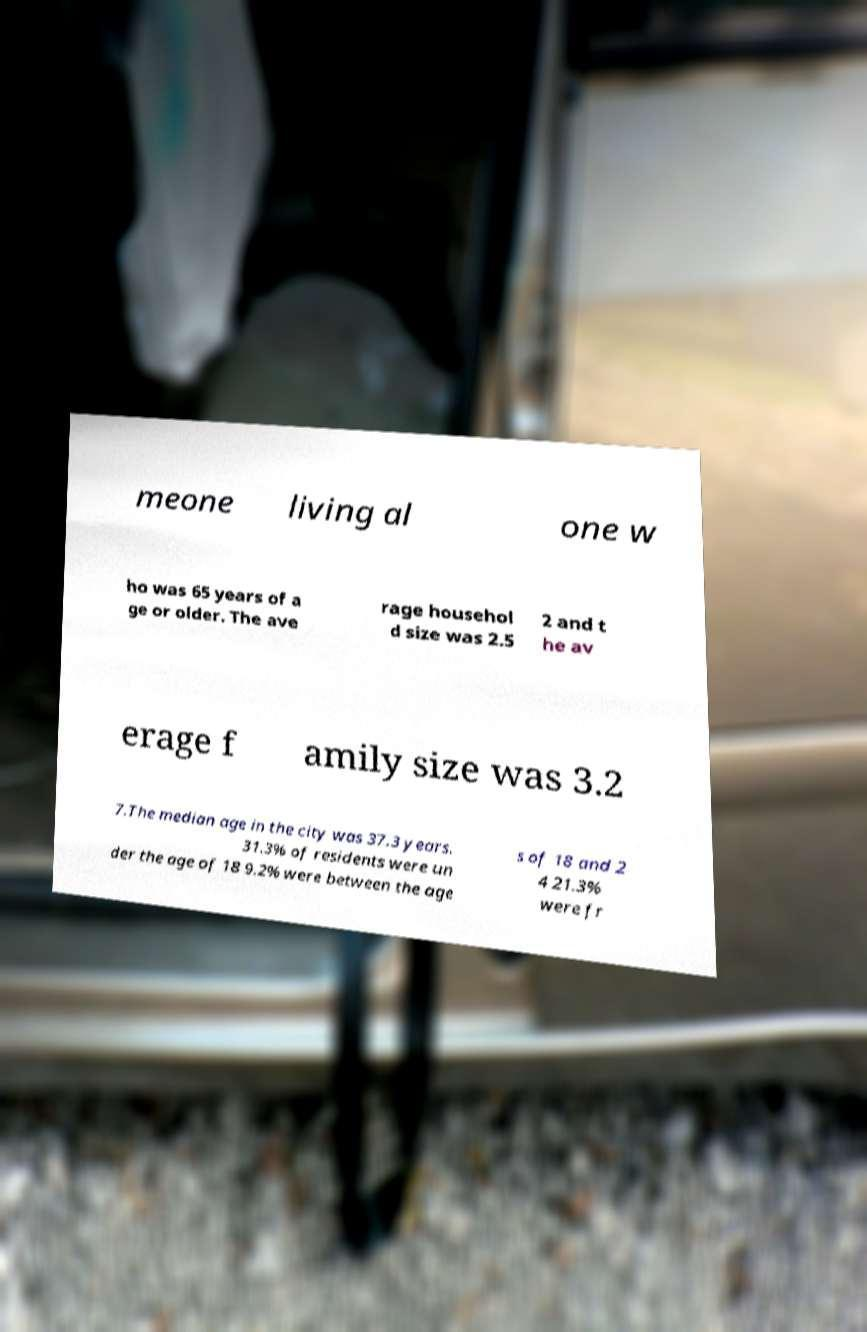What messages or text are displayed in this image? I need them in a readable, typed format. meone living al one w ho was 65 years of a ge or older. The ave rage househol d size was 2.5 2 and t he av erage f amily size was 3.2 7.The median age in the city was 37.3 years. 31.3% of residents were un der the age of 18 9.2% were between the age s of 18 and 2 4 21.3% were fr 